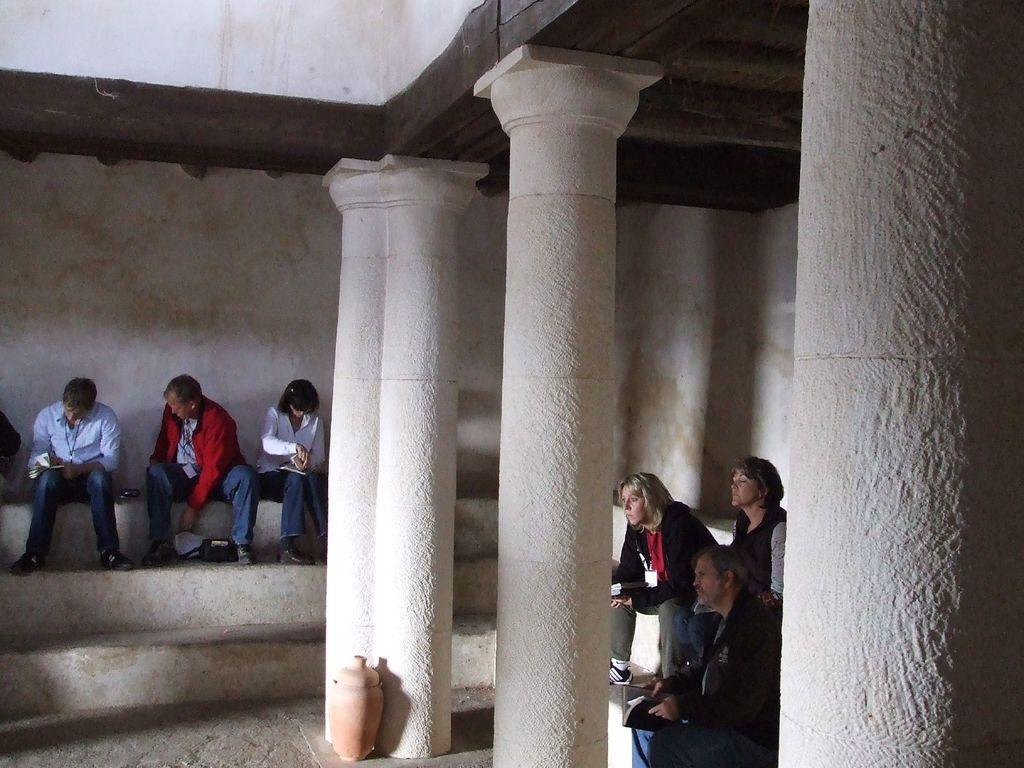What type of architectural feature is present in the image? There is a staircase in the image. What are the people in the image doing? There are groups of people sitting in the image. What other structural elements can be seen in the image? There are pillars in the image. What is the background behind the people in the image? There is a white wall behind the people in the image. What type of ship can be seen in the image? There is no ship present in the image; it features a staircase, groups of people sitting, pillars, and a white wall. 